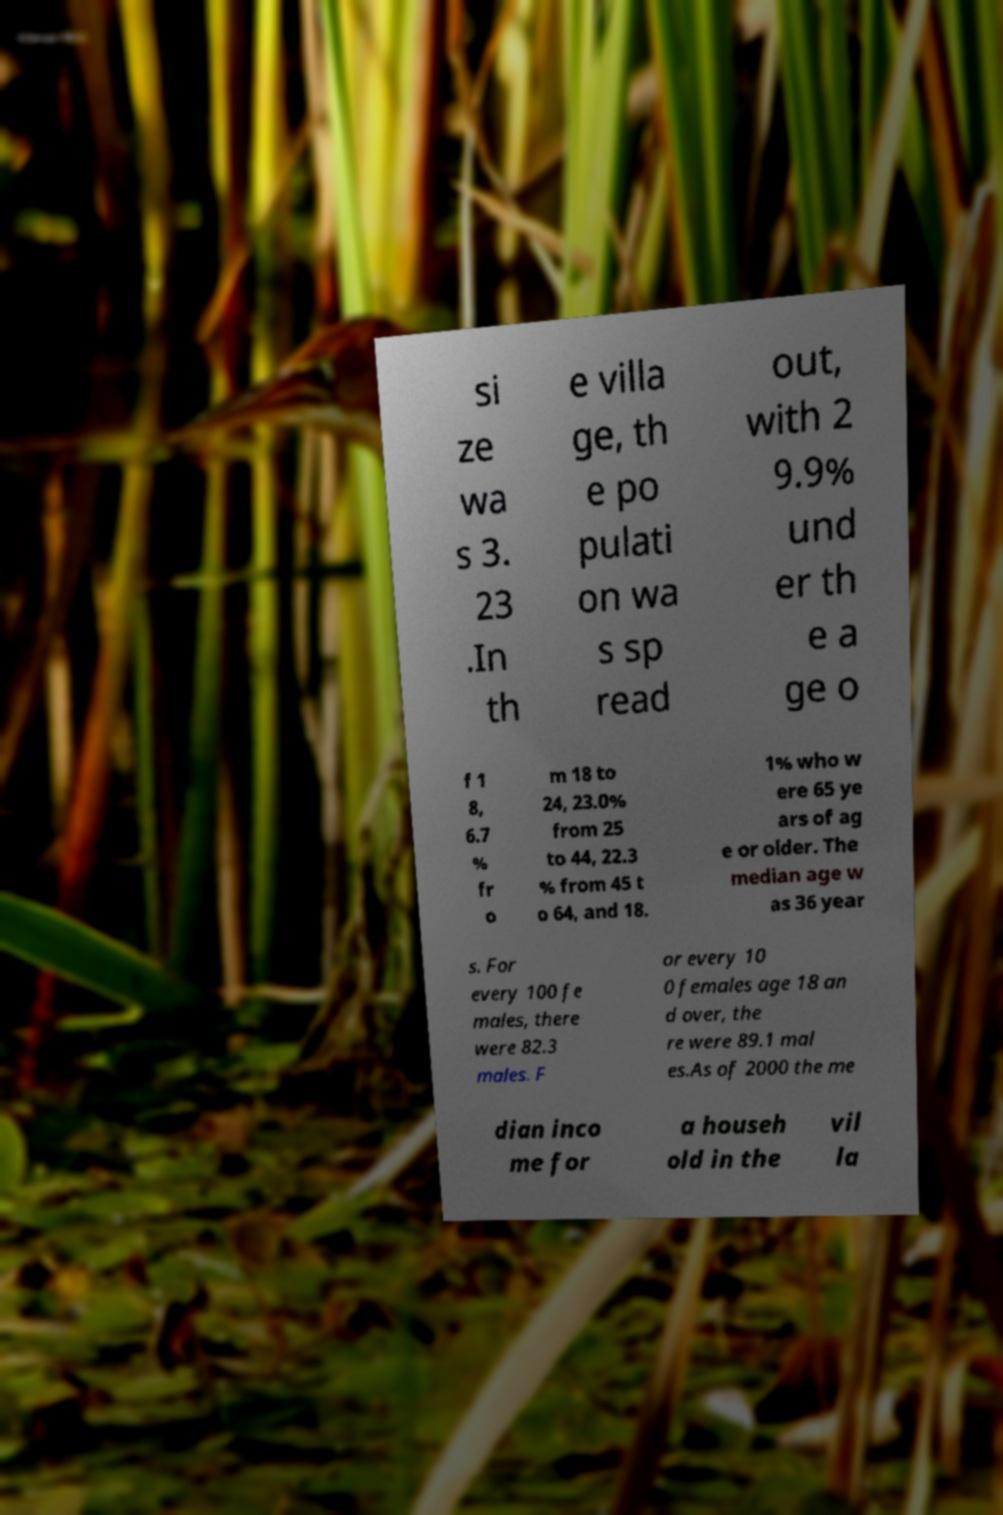I need the written content from this picture converted into text. Can you do that? si ze wa s 3. 23 .In th e villa ge, th e po pulati on wa s sp read out, with 2 9.9% und er th e a ge o f 1 8, 6.7 % fr o m 18 to 24, 23.0% from 25 to 44, 22.3 % from 45 t o 64, and 18. 1% who w ere 65 ye ars of ag e or older. The median age w as 36 year s. For every 100 fe males, there were 82.3 males. F or every 10 0 females age 18 an d over, the re were 89.1 mal es.As of 2000 the me dian inco me for a househ old in the vil la 